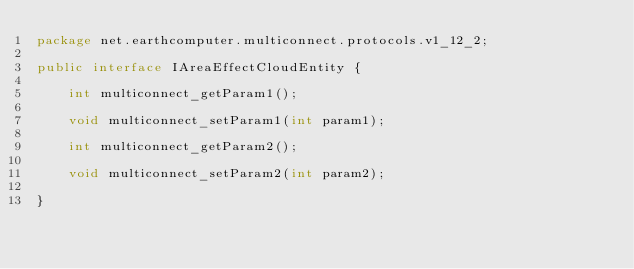<code> <loc_0><loc_0><loc_500><loc_500><_Java_>package net.earthcomputer.multiconnect.protocols.v1_12_2;

public interface IAreaEffectCloudEntity {

    int multiconnect_getParam1();

    void multiconnect_setParam1(int param1);

    int multiconnect_getParam2();

    void multiconnect_setParam2(int param2);

}
</code> 